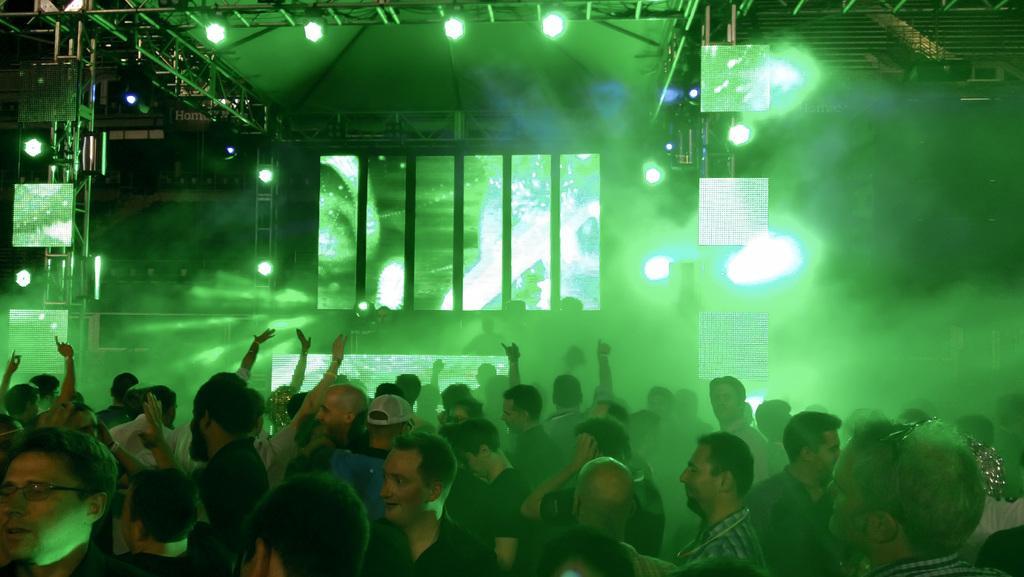In one or two sentences, can you explain what this image depicts? In the center of the image we can see a few people are standing and few people are dancing. In the background there is a wall, roof, lights, pole type structures and a few other objects. 